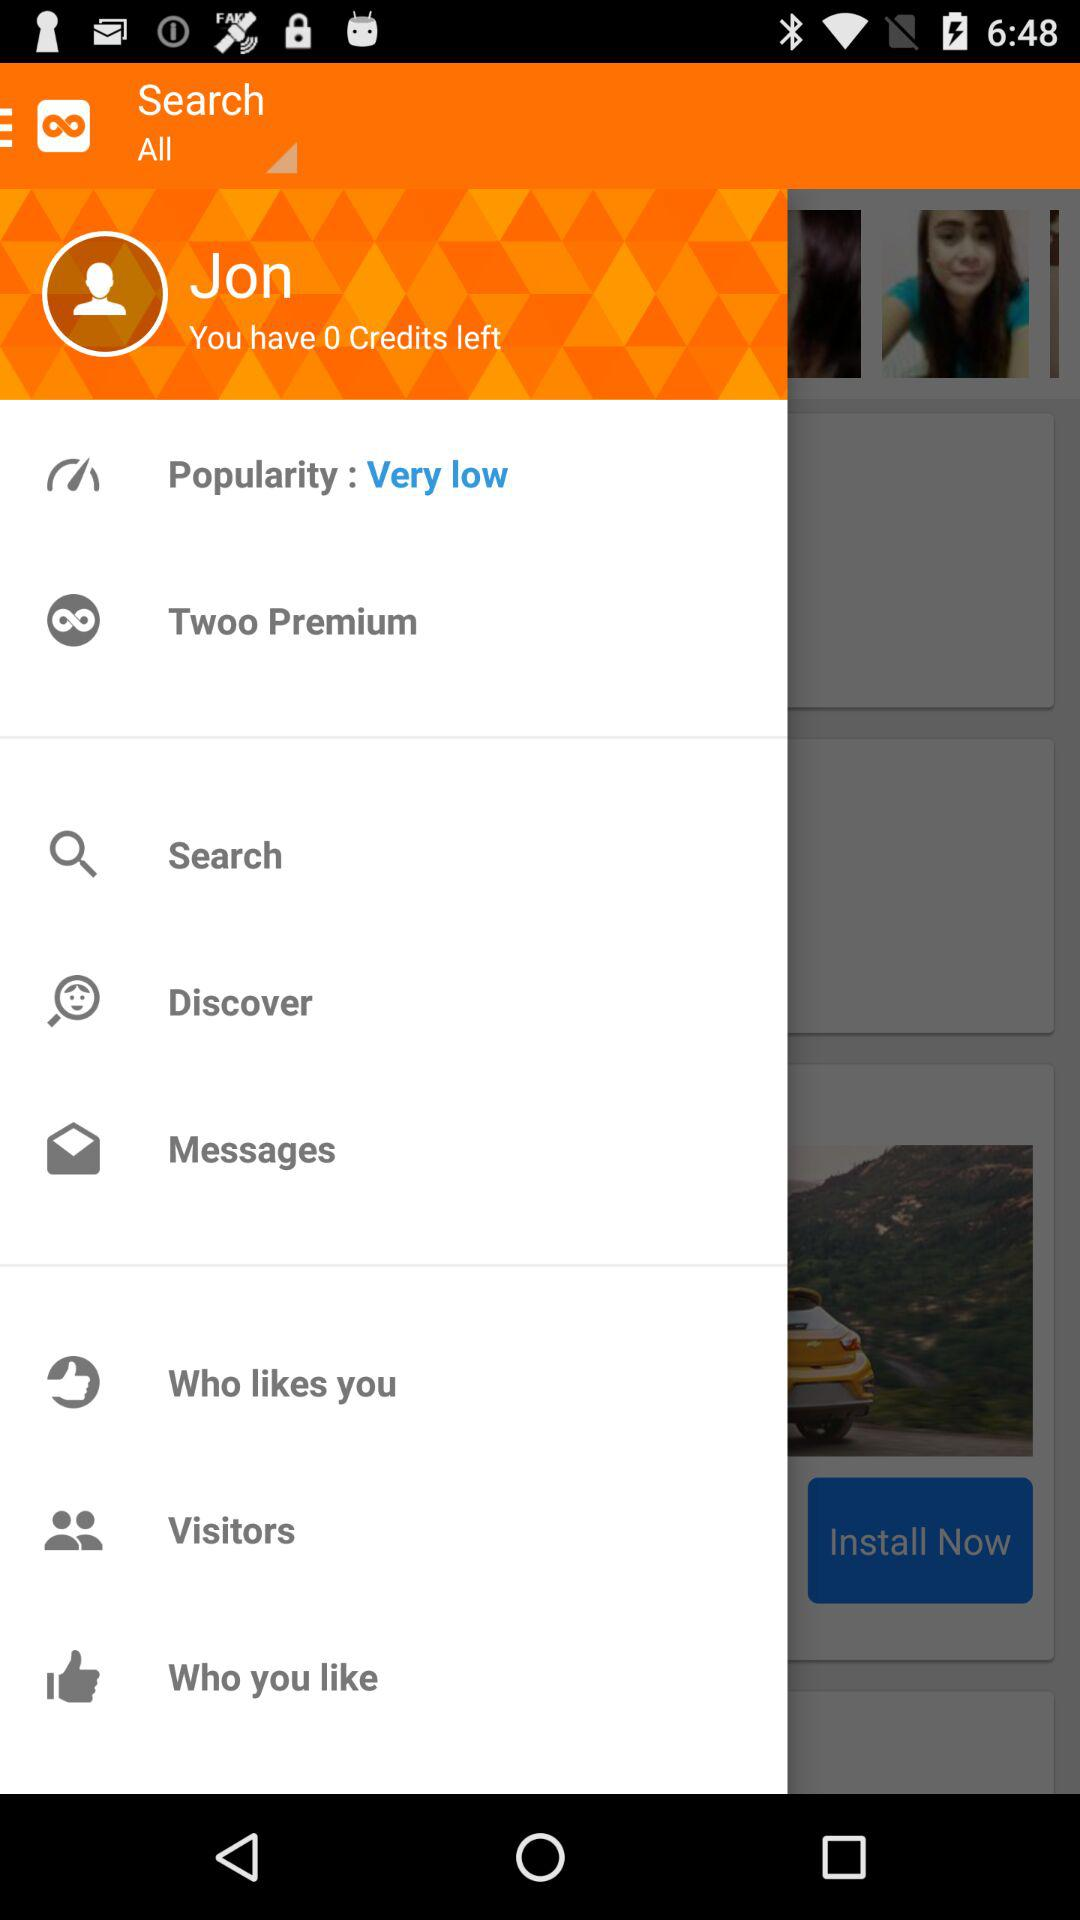What is the status of popularity? The status of popularity is "Very low". 